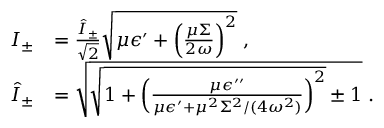Convert formula to latex. <formula><loc_0><loc_0><loc_500><loc_500>\begin{array} { r l } { I _ { \pm } } & { = \frac { \hat { I } _ { \pm } } { \sqrt { 2 } } \sqrt { \mu \epsilon ^ { \prime } + \left ( \frac { \mu \Sigma } { 2 \omega } \right ) ^ { 2 } } \, , } \\ { \hat { I } _ { \pm } } & { = \sqrt { \sqrt { 1 + \left ( \frac { \mu \epsilon ^ { \prime \prime } } { \mu \epsilon ^ { \prime } + \mu ^ { 2 } \Sigma ^ { 2 } / ( 4 \omega ^ { 2 } ) } \right ) ^ { 2 } } \pm 1 } \, . } \end{array}</formula> 